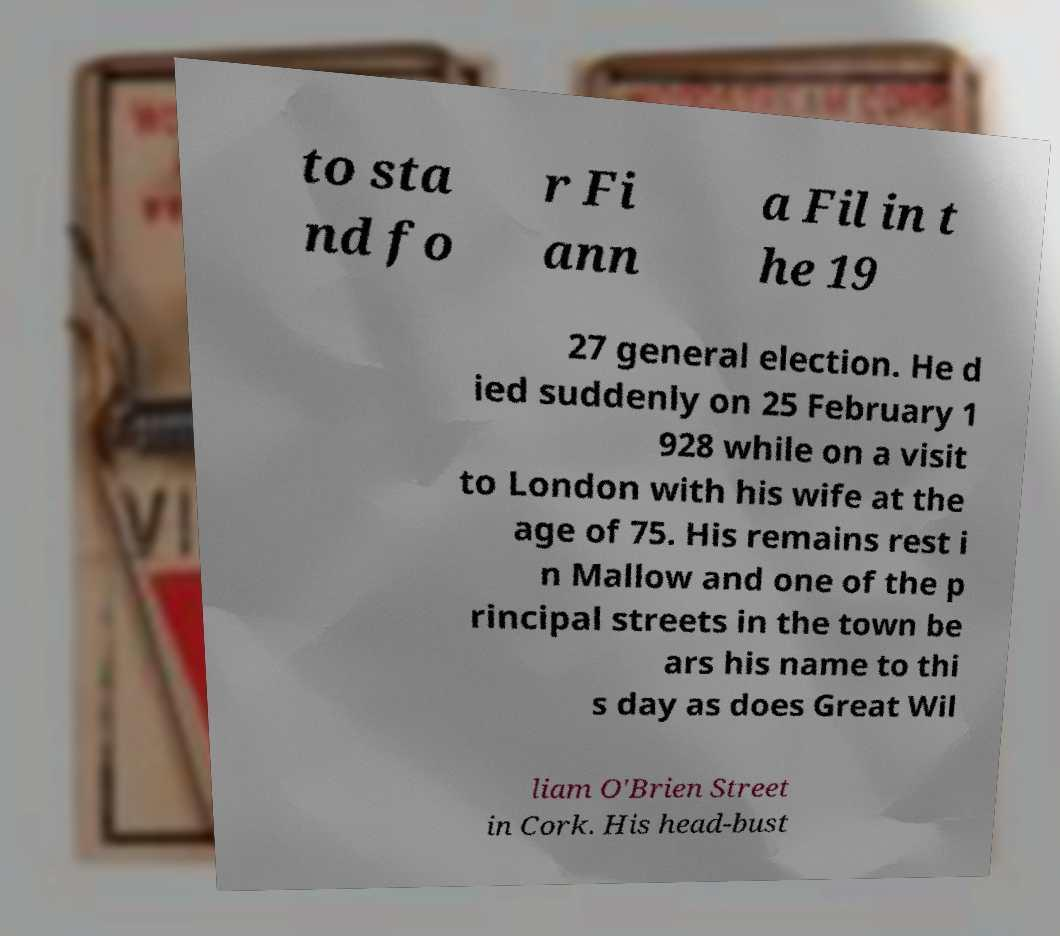Please read and relay the text visible in this image. What does it say? to sta nd fo r Fi ann a Fil in t he 19 27 general election. He d ied suddenly on 25 February 1 928 while on a visit to London with his wife at the age of 75. His remains rest i n Mallow and one of the p rincipal streets in the town be ars his name to thi s day as does Great Wil liam O'Brien Street in Cork. His head-bust 